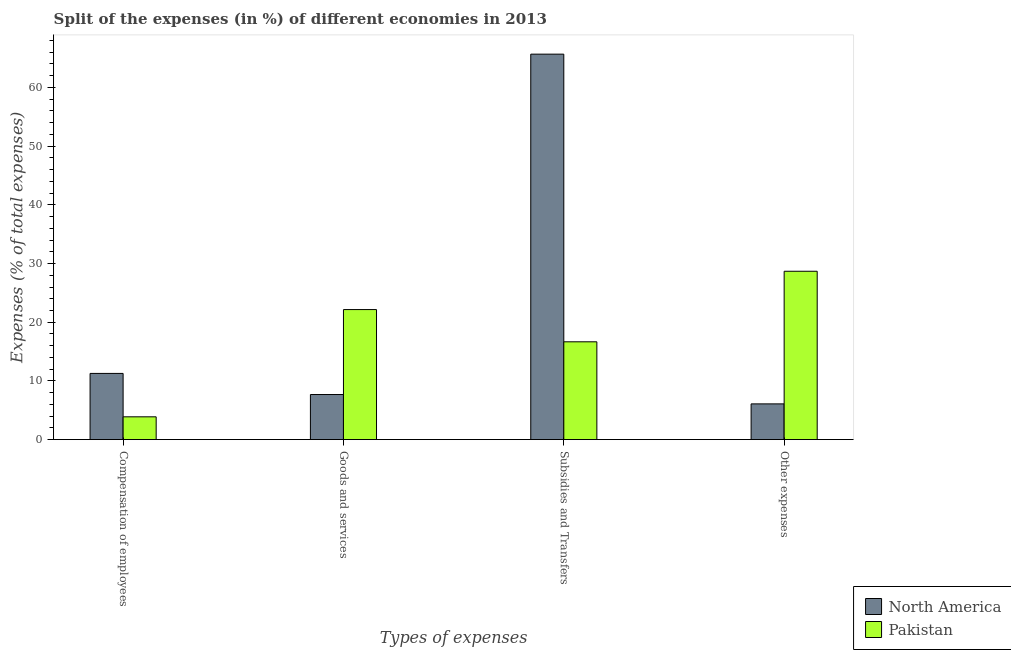Are the number of bars per tick equal to the number of legend labels?
Offer a terse response. Yes. Are the number of bars on each tick of the X-axis equal?
Ensure brevity in your answer.  Yes. How many bars are there on the 2nd tick from the right?
Give a very brief answer. 2. What is the label of the 2nd group of bars from the left?
Ensure brevity in your answer.  Goods and services. What is the percentage of amount spent on goods and services in North America?
Your answer should be very brief. 7.68. Across all countries, what is the maximum percentage of amount spent on subsidies?
Make the answer very short. 65.68. Across all countries, what is the minimum percentage of amount spent on compensation of employees?
Keep it short and to the point. 3.88. In which country was the percentage of amount spent on goods and services maximum?
Provide a short and direct response. Pakistan. In which country was the percentage of amount spent on other expenses minimum?
Make the answer very short. North America. What is the total percentage of amount spent on goods and services in the graph?
Your answer should be compact. 29.84. What is the difference between the percentage of amount spent on compensation of employees in Pakistan and that in North America?
Make the answer very short. -7.39. What is the difference between the percentage of amount spent on goods and services in North America and the percentage of amount spent on subsidies in Pakistan?
Your answer should be compact. -8.98. What is the average percentage of amount spent on subsidies per country?
Provide a short and direct response. 41.17. What is the difference between the percentage of amount spent on other expenses and percentage of amount spent on compensation of employees in Pakistan?
Ensure brevity in your answer.  24.8. What is the ratio of the percentage of amount spent on other expenses in Pakistan to that in North America?
Make the answer very short. 4.71. Is the difference between the percentage of amount spent on subsidies in Pakistan and North America greater than the difference between the percentage of amount spent on other expenses in Pakistan and North America?
Offer a very short reply. No. What is the difference between the highest and the second highest percentage of amount spent on other expenses?
Give a very brief answer. 22.6. What is the difference between the highest and the lowest percentage of amount spent on other expenses?
Your answer should be very brief. 22.6. In how many countries, is the percentage of amount spent on compensation of employees greater than the average percentage of amount spent on compensation of employees taken over all countries?
Offer a very short reply. 1. What does the 2nd bar from the left in Goods and services represents?
Offer a terse response. Pakistan. What does the 2nd bar from the right in Other expenses represents?
Provide a succinct answer. North America. How many bars are there?
Make the answer very short. 8. Are all the bars in the graph horizontal?
Offer a terse response. No. How many countries are there in the graph?
Provide a succinct answer. 2. What is the difference between two consecutive major ticks on the Y-axis?
Ensure brevity in your answer.  10. Does the graph contain any zero values?
Your answer should be very brief. No. Where does the legend appear in the graph?
Provide a short and direct response. Bottom right. What is the title of the graph?
Your response must be concise. Split of the expenses (in %) of different economies in 2013. What is the label or title of the X-axis?
Provide a succinct answer. Types of expenses. What is the label or title of the Y-axis?
Your response must be concise. Expenses (% of total expenses). What is the Expenses (% of total expenses) in North America in Compensation of employees?
Give a very brief answer. 11.28. What is the Expenses (% of total expenses) in Pakistan in Compensation of employees?
Keep it short and to the point. 3.88. What is the Expenses (% of total expenses) in North America in Goods and services?
Give a very brief answer. 7.68. What is the Expenses (% of total expenses) of Pakistan in Goods and services?
Your answer should be compact. 22.16. What is the Expenses (% of total expenses) of North America in Subsidies and Transfers?
Your answer should be very brief. 65.68. What is the Expenses (% of total expenses) in Pakistan in Subsidies and Transfers?
Give a very brief answer. 16.66. What is the Expenses (% of total expenses) of North America in Other expenses?
Ensure brevity in your answer.  6.09. What is the Expenses (% of total expenses) of Pakistan in Other expenses?
Your answer should be compact. 28.68. Across all Types of expenses, what is the maximum Expenses (% of total expenses) of North America?
Your answer should be very brief. 65.68. Across all Types of expenses, what is the maximum Expenses (% of total expenses) of Pakistan?
Keep it short and to the point. 28.68. Across all Types of expenses, what is the minimum Expenses (% of total expenses) of North America?
Your answer should be very brief. 6.09. Across all Types of expenses, what is the minimum Expenses (% of total expenses) in Pakistan?
Your response must be concise. 3.88. What is the total Expenses (% of total expenses) in North America in the graph?
Offer a terse response. 90.72. What is the total Expenses (% of total expenses) in Pakistan in the graph?
Give a very brief answer. 71.39. What is the difference between the Expenses (% of total expenses) of North America in Compensation of employees and that in Goods and services?
Make the answer very short. 3.6. What is the difference between the Expenses (% of total expenses) of Pakistan in Compensation of employees and that in Goods and services?
Your answer should be very brief. -18.27. What is the difference between the Expenses (% of total expenses) in North America in Compensation of employees and that in Subsidies and Transfers?
Offer a very short reply. -54.4. What is the difference between the Expenses (% of total expenses) of Pakistan in Compensation of employees and that in Subsidies and Transfers?
Provide a succinct answer. -12.78. What is the difference between the Expenses (% of total expenses) of North America in Compensation of employees and that in Other expenses?
Your answer should be very brief. 5.19. What is the difference between the Expenses (% of total expenses) in Pakistan in Compensation of employees and that in Other expenses?
Your answer should be very brief. -24.8. What is the difference between the Expenses (% of total expenses) of North America in Goods and services and that in Subsidies and Transfers?
Make the answer very short. -58. What is the difference between the Expenses (% of total expenses) of Pakistan in Goods and services and that in Subsidies and Transfers?
Your answer should be very brief. 5.49. What is the difference between the Expenses (% of total expenses) of North America in Goods and services and that in Other expenses?
Ensure brevity in your answer.  1.59. What is the difference between the Expenses (% of total expenses) in Pakistan in Goods and services and that in Other expenses?
Provide a succinct answer. -6.53. What is the difference between the Expenses (% of total expenses) of North America in Subsidies and Transfers and that in Other expenses?
Make the answer very short. 59.59. What is the difference between the Expenses (% of total expenses) of Pakistan in Subsidies and Transfers and that in Other expenses?
Provide a short and direct response. -12.02. What is the difference between the Expenses (% of total expenses) of North America in Compensation of employees and the Expenses (% of total expenses) of Pakistan in Goods and services?
Make the answer very short. -10.88. What is the difference between the Expenses (% of total expenses) in North America in Compensation of employees and the Expenses (% of total expenses) in Pakistan in Subsidies and Transfers?
Your answer should be compact. -5.39. What is the difference between the Expenses (% of total expenses) of North America in Compensation of employees and the Expenses (% of total expenses) of Pakistan in Other expenses?
Provide a short and direct response. -17.41. What is the difference between the Expenses (% of total expenses) in North America in Goods and services and the Expenses (% of total expenses) in Pakistan in Subsidies and Transfers?
Offer a terse response. -8.98. What is the difference between the Expenses (% of total expenses) of North America in Goods and services and the Expenses (% of total expenses) of Pakistan in Other expenses?
Provide a short and direct response. -21. What is the difference between the Expenses (% of total expenses) of North America in Subsidies and Transfers and the Expenses (% of total expenses) of Pakistan in Other expenses?
Offer a terse response. 36.99. What is the average Expenses (% of total expenses) in North America per Types of expenses?
Keep it short and to the point. 22.68. What is the average Expenses (% of total expenses) of Pakistan per Types of expenses?
Make the answer very short. 17.85. What is the difference between the Expenses (% of total expenses) in North America and Expenses (% of total expenses) in Pakistan in Compensation of employees?
Offer a terse response. 7.39. What is the difference between the Expenses (% of total expenses) in North America and Expenses (% of total expenses) in Pakistan in Goods and services?
Offer a very short reply. -14.48. What is the difference between the Expenses (% of total expenses) of North America and Expenses (% of total expenses) of Pakistan in Subsidies and Transfers?
Keep it short and to the point. 49.01. What is the difference between the Expenses (% of total expenses) of North America and Expenses (% of total expenses) of Pakistan in Other expenses?
Ensure brevity in your answer.  -22.6. What is the ratio of the Expenses (% of total expenses) of North America in Compensation of employees to that in Goods and services?
Keep it short and to the point. 1.47. What is the ratio of the Expenses (% of total expenses) of Pakistan in Compensation of employees to that in Goods and services?
Provide a short and direct response. 0.18. What is the ratio of the Expenses (% of total expenses) of North America in Compensation of employees to that in Subsidies and Transfers?
Provide a short and direct response. 0.17. What is the ratio of the Expenses (% of total expenses) in Pakistan in Compensation of employees to that in Subsidies and Transfers?
Keep it short and to the point. 0.23. What is the ratio of the Expenses (% of total expenses) in North America in Compensation of employees to that in Other expenses?
Offer a very short reply. 1.85. What is the ratio of the Expenses (% of total expenses) of Pakistan in Compensation of employees to that in Other expenses?
Your response must be concise. 0.14. What is the ratio of the Expenses (% of total expenses) in North America in Goods and services to that in Subsidies and Transfers?
Your answer should be compact. 0.12. What is the ratio of the Expenses (% of total expenses) in Pakistan in Goods and services to that in Subsidies and Transfers?
Make the answer very short. 1.33. What is the ratio of the Expenses (% of total expenses) in North America in Goods and services to that in Other expenses?
Offer a terse response. 1.26. What is the ratio of the Expenses (% of total expenses) of Pakistan in Goods and services to that in Other expenses?
Ensure brevity in your answer.  0.77. What is the ratio of the Expenses (% of total expenses) of North America in Subsidies and Transfers to that in Other expenses?
Your answer should be very brief. 10.79. What is the ratio of the Expenses (% of total expenses) in Pakistan in Subsidies and Transfers to that in Other expenses?
Keep it short and to the point. 0.58. What is the difference between the highest and the second highest Expenses (% of total expenses) in North America?
Offer a terse response. 54.4. What is the difference between the highest and the second highest Expenses (% of total expenses) in Pakistan?
Give a very brief answer. 6.53. What is the difference between the highest and the lowest Expenses (% of total expenses) in North America?
Give a very brief answer. 59.59. What is the difference between the highest and the lowest Expenses (% of total expenses) in Pakistan?
Provide a succinct answer. 24.8. 